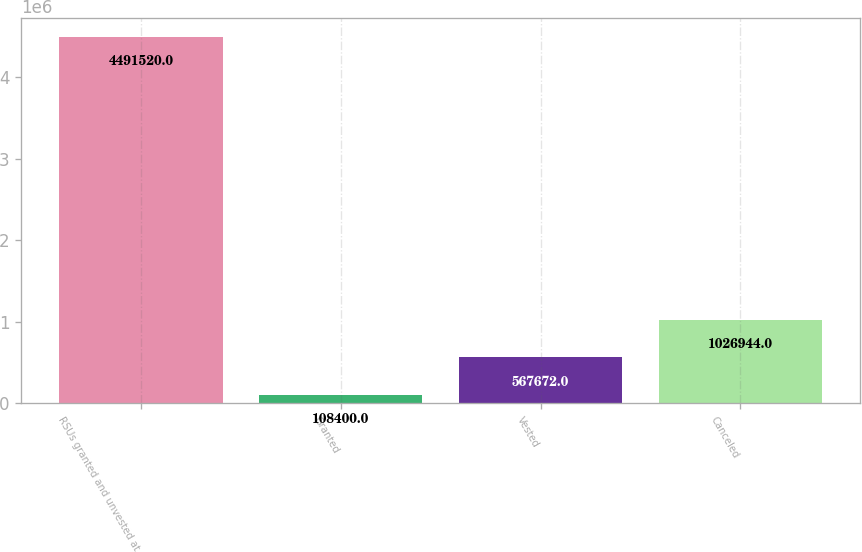Convert chart to OTSL. <chart><loc_0><loc_0><loc_500><loc_500><bar_chart><fcel>RSUs granted and unvested at<fcel>Granted<fcel>Vested<fcel>Canceled<nl><fcel>4.49152e+06<fcel>108400<fcel>567672<fcel>1.02694e+06<nl></chart> 